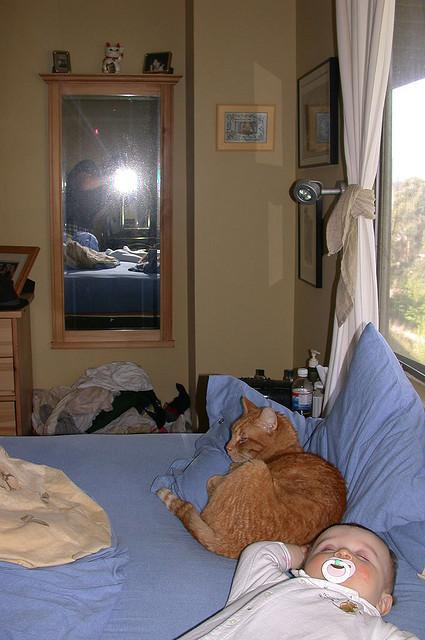What is the cause of the bright spot in the center of the mirror on the wall?

Choices:
A) lamp
B) lighter
C) flashlight
D) camera flash camera flash 